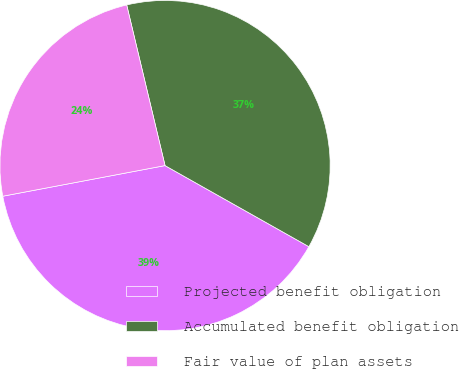Convert chart. <chart><loc_0><loc_0><loc_500><loc_500><pie_chart><fcel>Projected benefit obligation<fcel>Accumulated benefit obligation<fcel>Fair value of plan assets<nl><fcel>38.86%<fcel>36.9%<fcel>24.24%<nl></chart> 